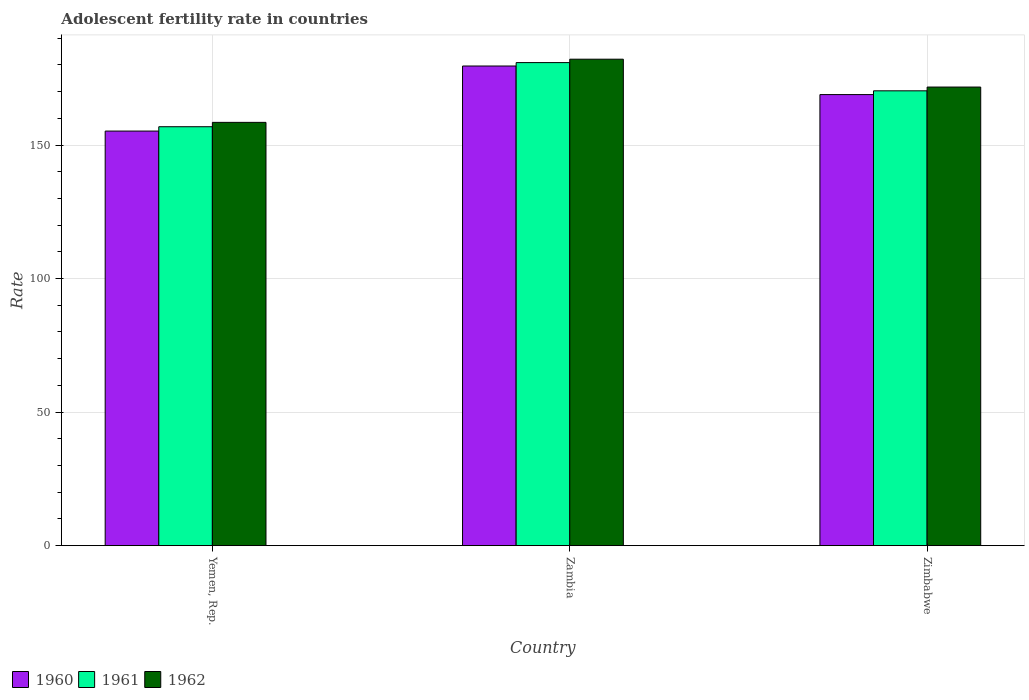How many groups of bars are there?
Offer a terse response. 3. How many bars are there on the 1st tick from the left?
Provide a short and direct response. 3. How many bars are there on the 2nd tick from the right?
Your answer should be compact. 3. What is the label of the 2nd group of bars from the left?
Your answer should be very brief. Zambia. What is the adolescent fertility rate in 1961 in Zimbabwe?
Ensure brevity in your answer.  170.28. Across all countries, what is the maximum adolescent fertility rate in 1961?
Ensure brevity in your answer.  180.85. Across all countries, what is the minimum adolescent fertility rate in 1960?
Give a very brief answer. 155.21. In which country was the adolescent fertility rate in 1962 maximum?
Offer a terse response. Zambia. In which country was the adolescent fertility rate in 1962 minimum?
Keep it short and to the point. Yemen, Rep. What is the total adolescent fertility rate in 1962 in the graph?
Give a very brief answer. 512.29. What is the difference between the adolescent fertility rate in 1960 in Yemen, Rep. and that in Zambia?
Your answer should be compact. -24.36. What is the difference between the adolescent fertility rate in 1962 in Yemen, Rep. and the adolescent fertility rate in 1961 in Zimbabwe?
Ensure brevity in your answer.  -11.81. What is the average adolescent fertility rate in 1961 per country?
Provide a succinct answer. 169.33. What is the difference between the adolescent fertility rate of/in 1962 and adolescent fertility rate of/in 1961 in Yemen, Rep.?
Give a very brief answer. 1.63. What is the ratio of the adolescent fertility rate in 1960 in Yemen, Rep. to that in Zimbabwe?
Ensure brevity in your answer.  0.92. Is the adolescent fertility rate in 1960 in Zambia less than that in Zimbabwe?
Keep it short and to the point. No. What is the difference between the highest and the second highest adolescent fertility rate in 1960?
Provide a succinct answer. -10.7. What is the difference between the highest and the lowest adolescent fertility rate in 1960?
Give a very brief answer. 24.36. How many bars are there?
Your response must be concise. 9. How many countries are there in the graph?
Your answer should be very brief. 3. What is the difference between two consecutive major ticks on the Y-axis?
Make the answer very short. 50. Does the graph contain any zero values?
Provide a short and direct response. No. How are the legend labels stacked?
Your response must be concise. Horizontal. What is the title of the graph?
Your answer should be compact. Adolescent fertility rate in countries. What is the label or title of the X-axis?
Ensure brevity in your answer.  Country. What is the label or title of the Y-axis?
Make the answer very short. Rate. What is the Rate of 1960 in Yemen, Rep.?
Give a very brief answer. 155.21. What is the Rate in 1961 in Yemen, Rep.?
Make the answer very short. 156.85. What is the Rate in 1962 in Yemen, Rep.?
Your response must be concise. 158.48. What is the Rate in 1960 in Zambia?
Ensure brevity in your answer.  179.58. What is the Rate in 1961 in Zambia?
Offer a very short reply. 180.85. What is the Rate of 1962 in Zambia?
Give a very brief answer. 182.12. What is the Rate of 1960 in Zimbabwe?
Make the answer very short. 168.87. What is the Rate of 1961 in Zimbabwe?
Ensure brevity in your answer.  170.28. What is the Rate of 1962 in Zimbabwe?
Your answer should be compact. 171.7. Across all countries, what is the maximum Rate in 1960?
Ensure brevity in your answer.  179.58. Across all countries, what is the maximum Rate of 1961?
Make the answer very short. 180.85. Across all countries, what is the maximum Rate in 1962?
Your answer should be compact. 182.12. Across all countries, what is the minimum Rate in 1960?
Give a very brief answer. 155.21. Across all countries, what is the minimum Rate of 1961?
Make the answer very short. 156.85. Across all countries, what is the minimum Rate in 1962?
Ensure brevity in your answer.  158.48. What is the total Rate of 1960 in the graph?
Your answer should be very brief. 503.66. What is the total Rate in 1961 in the graph?
Provide a succinct answer. 507.98. What is the total Rate of 1962 in the graph?
Ensure brevity in your answer.  512.29. What is the difference between the Rate of 1960 in Yemen, Rep. and that in Zambia?
Your answer should be compact. -24.36. What is the difference between the Rate of 1961 in Yemen, Rep. and that in Zambia?
Provide a succinct answer. -24. What is the difference between the Rate of 1962 in Yemen, Rep. and that in Zambia?
Provide a short and direct response. -23.65. What is the difference between the Rate in 1960 in Yemen, Rep. and that in Zimbabwe?
Your answer should be compact. -13.66. What is the difference between the Rate of 1961 in Yemen, Rep. and that in Zimbabwe?
Provide a succinct answer. -13.44. What is the difference between the Rate of 1962 in Yemen, Rep. and that in Zimbabwe?
Provide a succinct answer. -13.22. What is the difference between the Rate of 1960 in Zambia and that in Zimbabwe?
Your answer should be compact. 10.7. What is the difference between the Rate of 1961 in Zambia and that in Zimbabwe?
Your answer should be compact. 10.56. What is the difference between the Rate in 1962 in Zambia and that in Zimbabwe?
Your response must be concise. 10.43. What is the difference between the Rate in 1960 in Yemen, Rep. and the Rate in 1961 in Zambia?
Keep it short and to the point. -25.64. What is the difference between the Rate in 1960 in Yemen, Rep. and the Rate in 1962 in Zambia?
Provide a short and direct response. -26.91. What is the difference between the Rate of 1961 in Yemen, Rep. and the Rate of 1962 in Zambia?
Offer a very short reply. -25.28. What is the difference between the Rate in 1960 in Yemen, Rep. and the Rate in 1961 in Zimbabwe?
Provide a succinct answer. -15.07. What is the difference between the Rate in 1960 in Yemen, Rep. and the Rate in 1962 in Zimbabwe?
Provide a short and direct response. -16.48. What is the difference between the Rate in 1961 in Yemen, Rep. and the Rate in 1962 in Zimbabwe?
Your response must be concise. -14.85. What is the difference between the Rate in 1960 in Zambia and the Rate in 1961 in Zimbabwe?
Offer a terse response. 9.29. What is the difference between the Rate of 1960 in Zambia and the Rate of 1962 in Zimbabwe?
Keep it short and to the point. 7.88. What is the difference between the Rate of 1961 in Zambia and the Rate of 1962 in Zimbabwe?
Your response must be concise. 9.15. What is the average Rate of 1960 per country?
Provide a short and direct response. 167.89. What is the average Rate of 1961 per country?
Your answer should be very brief. 169.33. What is the average Rate in 1962 per country?
Ensure brevity in your answer.  170.76. What is the difference between the Rate in 1960 and Rate in 1961 in Yemen, Rep.?
Offer a very short reply. -1.63. What is the difference between the Rate of 1960 and Rate of 1962 in Yemen, Rep.?
Provide a short and direct response. -3.26. What is the difference between the Rate in 1961 and Rate in 1962 in Yemen, Rep.?
Keep it short and to the point. -1.63. What is the difference between the Rate of 1960 and Rate of 1961 in Zambia?
Offer a very short reply. -1.27. What is the difference between the Rate in 1960 and Rate in 1962 in Zambia?
Ensure brevity in your answer.  -2.55. What is the difference between the Rate of 1961 and Rate of 1962 in Zambia?
Offer a very short reply. -1.27. What is the difference between the Rate of 1960 and Rate of 1961 in Zimbabwe?
Make the answer very short. -1.41. What is the difference between the Rate of 1960 and Rate of 1962 in Zimbabwe?
Your response must be concise. -2.82. What is the difference between the Rate in 1961 and Rate in 1962 in Zimbabwe?
Give a very brief answer. -1.41. What is the ratio of the Rate of 1960 in Yemen, Rep. to that in Zambia?
Offer a very short reply. 0.86. What is the ratio of the Rate in 1961 in Yemen, Rep. to that in Zambia?
Provide a succinct answer. 0.87. What is the ratio of the Rate of 1962 in Yemen, Rep. to that in Zambia?
Offer a terse response. 0.87. What is the ratio of the Rate of 1960 in Yemen, Rep. to that in Zimbabwe?
Provide a succinct answer. 0.92. What is the ratio of the Rate in 1961 in Yemen, Rep. to that in Zimbabwe?
Provide a short and direct response. 0.92. What is the ratio of the Rate in 1962 in Yemen, Rep. to that in Zimbabwe?
Ensure brevity in your answer.  0.92. What is the ratio of the Rate of 1960 in Zambia to that in Zimbabwe?
Offer a very short reply. 1.06. What is the ratio of the Rate of 1961 in Zambia to that in Zimbabwe?
Your response must be concise. 1.06. What is the ratio of the Rate of 1962 in Zambia to that in Zimbabwe?
Your response must be concise. 1.06. What is the difference between the highest and the second highest Rate of 1960?
Keep it short and to the point. 10.7. What is the difference between the highest and the second highest Rate of 1961?
Your answer should be compact. 10.56. What is the difference between the highest and the second highest Rate in 1962?
Make the answer very short. 10.43. What is the difference between the highest and the lowest Rate of 1960?
Ensure brevity in your answer.  24.36. What is the difference between the highest and the lowest Rate in 1961?
Offer a very short reply. 24. What is the difference between the highest and the lowest Rate in 1962?
Offer a very short reply. 23.65. 